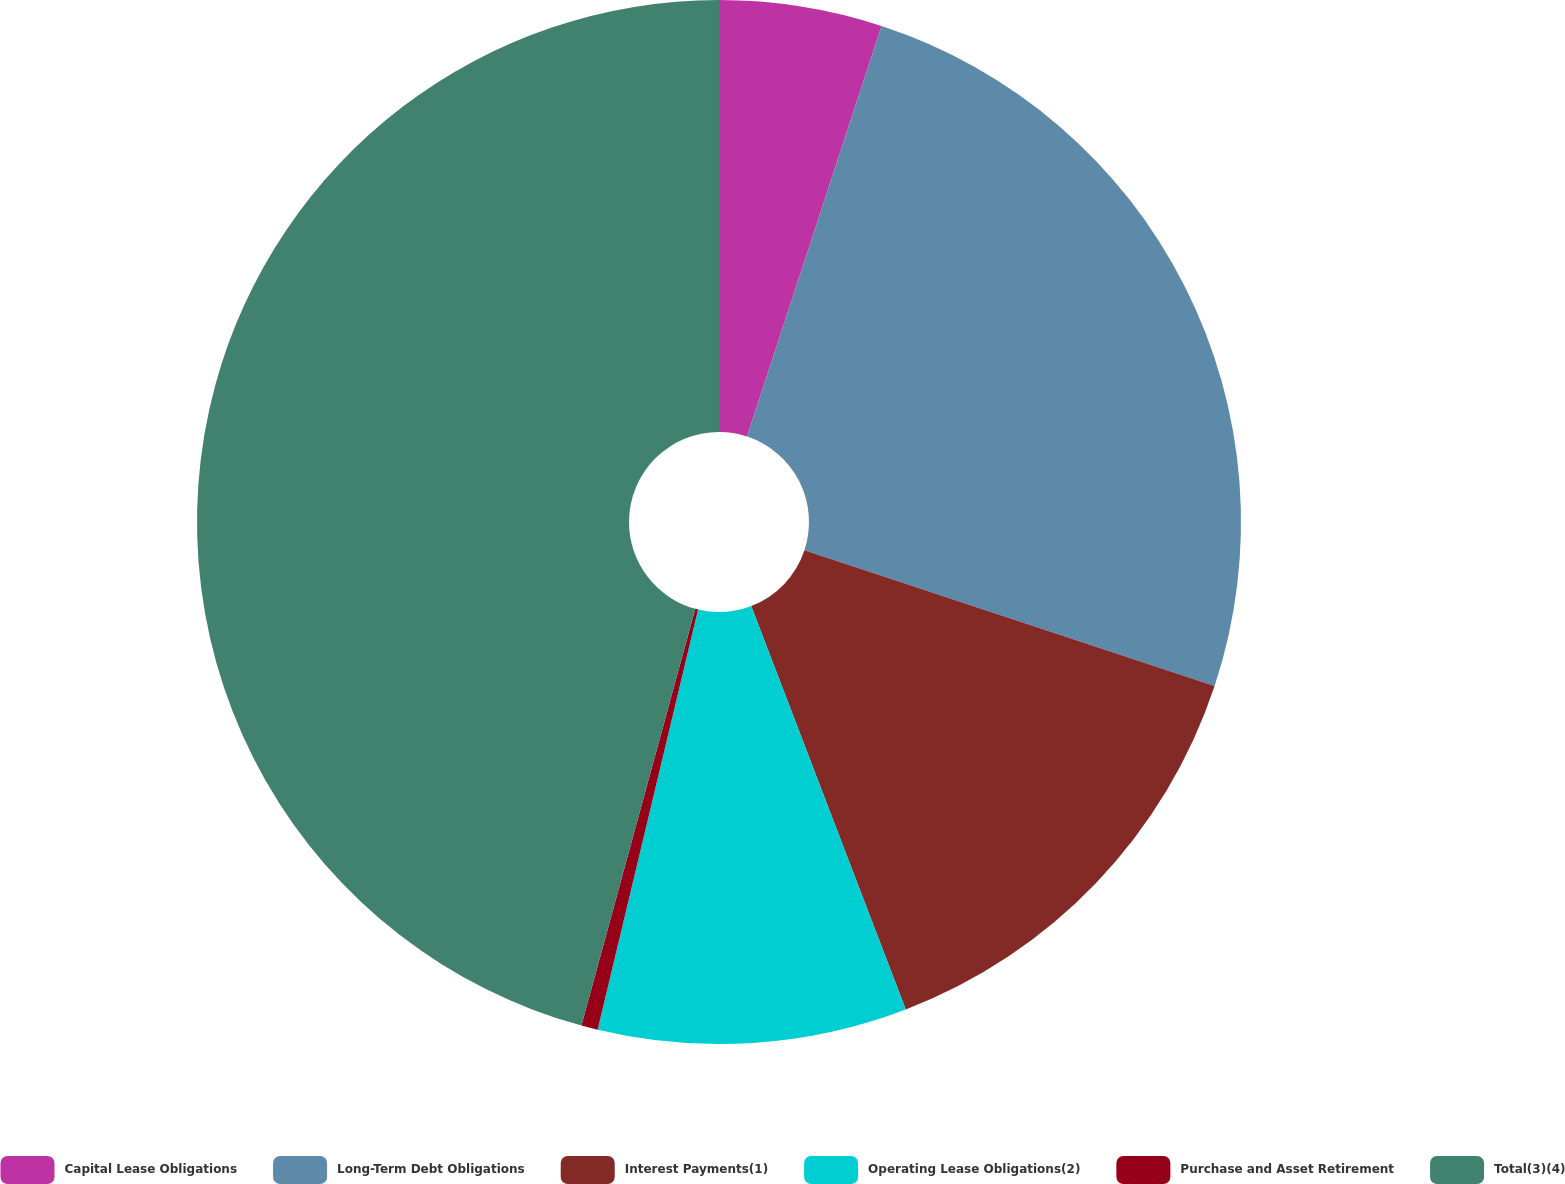<chart> <loc_0><loc_0><loc_500><loc_500><pie_chart><fcel>Capital Lease Obligations<fcel>Long-Term Debt Obligations<fcel>Interest Payments(1)<fcel>Operating Lease Obligations(2)<fcel>Purchase and Asset Retirement<fcel>Total(3)(4)<nl><fcel>5.04%<fcel>25.05%<fcel>14.09%<fcel>9.56%<fcel>0.51%<fcel>45.76%<nl></chart> 